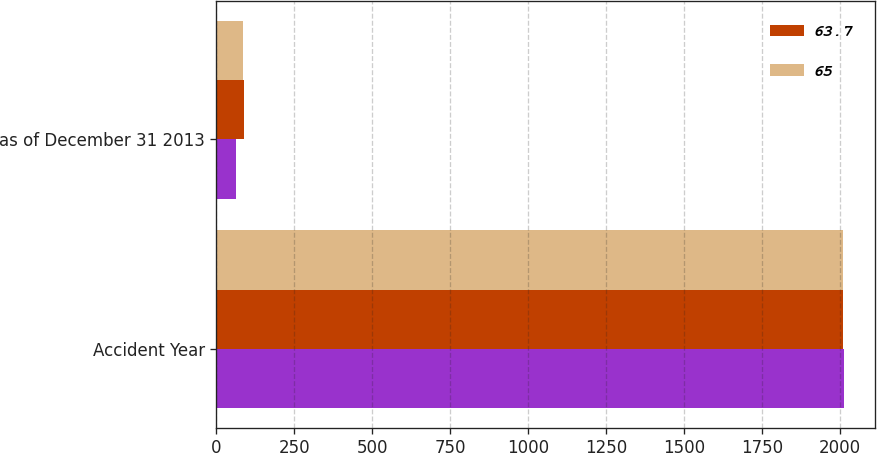Convert chart to OTSL. <chart><loc_0><loc_0><loc_500><loc_500><stacked_bar_chart><ecel><fcel>Accident Year<fcel>as of December 31 2013<nl><fcel>nan<fcel>2013<fcel>64<nl><fcel>63.7<fcel>2011<fcel>88<nl><fcel>65<fcel>2011<fcel>85.9<nl></chart> 